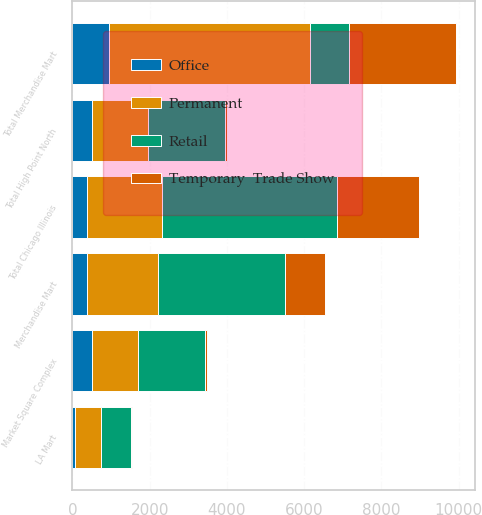Convert chart. <chart><loc_0><loc_0><loc_500><loc_500><stacked_bar_chart><ecel><fcel>Merchandise Mart<fcel>Total Chicago Illinois<fcel>Market Square Complex<fcel>Total High Point North<fcel>LA Mart<fcel>Total Merchandise Mart<nl><fcel>Retail<fcel>3301<fcel>4530<fcel>1750<fcel>2010<fcel>781<fcel>1028<nl><fcel>Temporary  Trade Show<fcel>1028<fcel>2134<fcel>32<fcel>32<fcel>32<fcel>2757<nl><fcel>Permanent<fcel>1823<fcel>1927<fcel>1184<fcel>1444<fcel>686<fcel>5193<nl><fcel>Office<fcel>386<fcel>386<fcel>506<fcel>506<fcel>54<fcel>946<nl></chart> 